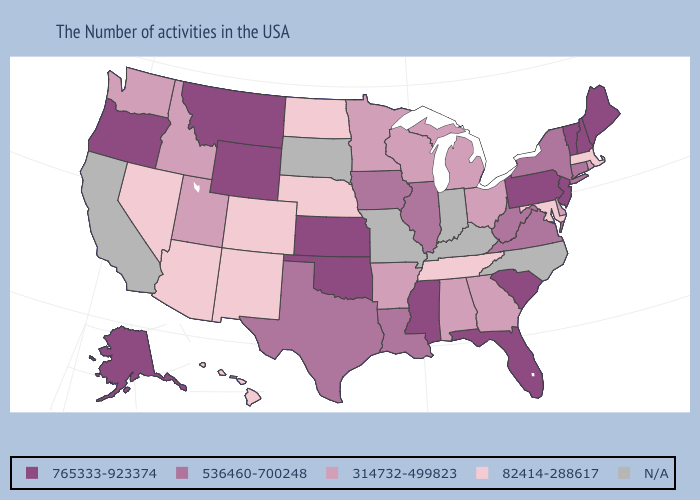Name the states that have a value in the range 536460-700248?
Write a very short answer. Connecticut, New York, Virginia, West Virginia, Illinois, Louisiana, Iowa, Texas. Name the states that have a value in the range N/A?
Answer briefly. North Carolina, Kentucky, Indiana, Missouri, South Dakota, California. Which states have the highest value in the USA?
Concise answer only. Maine, New Hampshire, Vermont, New Jersey, Pennsylvania, South Carolina, Florida, Mississippi, Kansas, Oklahoma, Wyoming, Montana, Oregon, Alaska. Name the states that have a value in the range N/A?
Give a very brief answer. North Carolina, Kentucky, Indiana, Missouri, South Dakota, California. What is the highest value in states that border Montana?
Answer briefly. 765333-923374. What is the value of Virginia?
Be succinct. 536460-700248. What is the highest value in the Northeast ?
Quick response, please. 765333-923374. What is the lowest value in states that border California?
Quick response, please. 82414-288617. What is the value of Kansas?
Write a very short answer. 765333-923374. What is the lowest value in the USA?
Quick response, please. 82414-288617. Name the states that have a value in the range 765333-923374?
Write a very short answer. Maine, New Hampshire, Vermont, New Jersey, Pennsylvania, South Carolina, Florida, Mississippi, Kansas, Oklahoma, Wyoming, Montana, Oregon, Alaska. What is the value of Texas?
Short answer required. 536460-700248. Name the states that have a value in the range 765333-923374?
Concise answer only. Maine, New Hampshire, Vermont, New Jersey, Pennsylvania, South Carolina, Florida, Mississippi, Kansas, Oklahoma, Wyoming, Montana, Oregon, Alaska. What is the lowest value in states that border Tennessee?
Keep it brief. 314732-499823. 